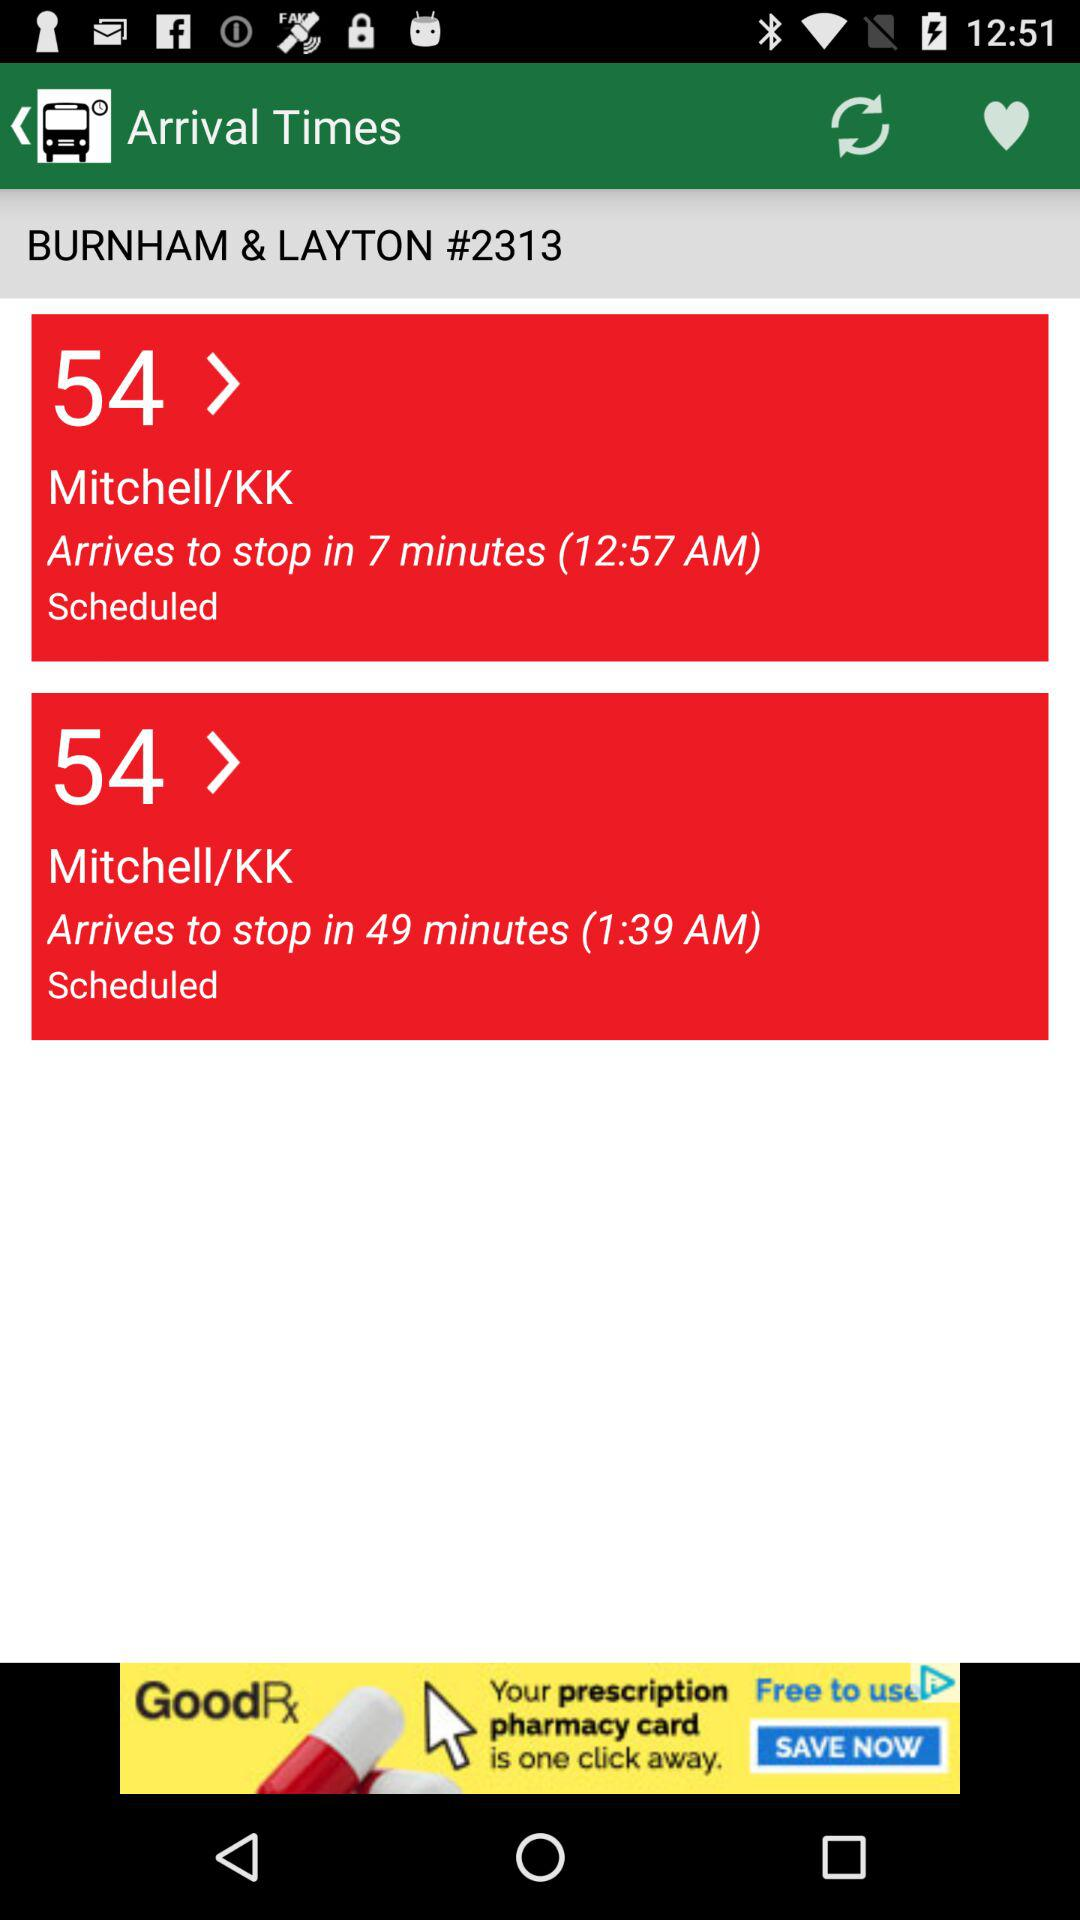What is the number of "BURNHAM & LAYTON" bus stop? The bus stop number is 2313. 